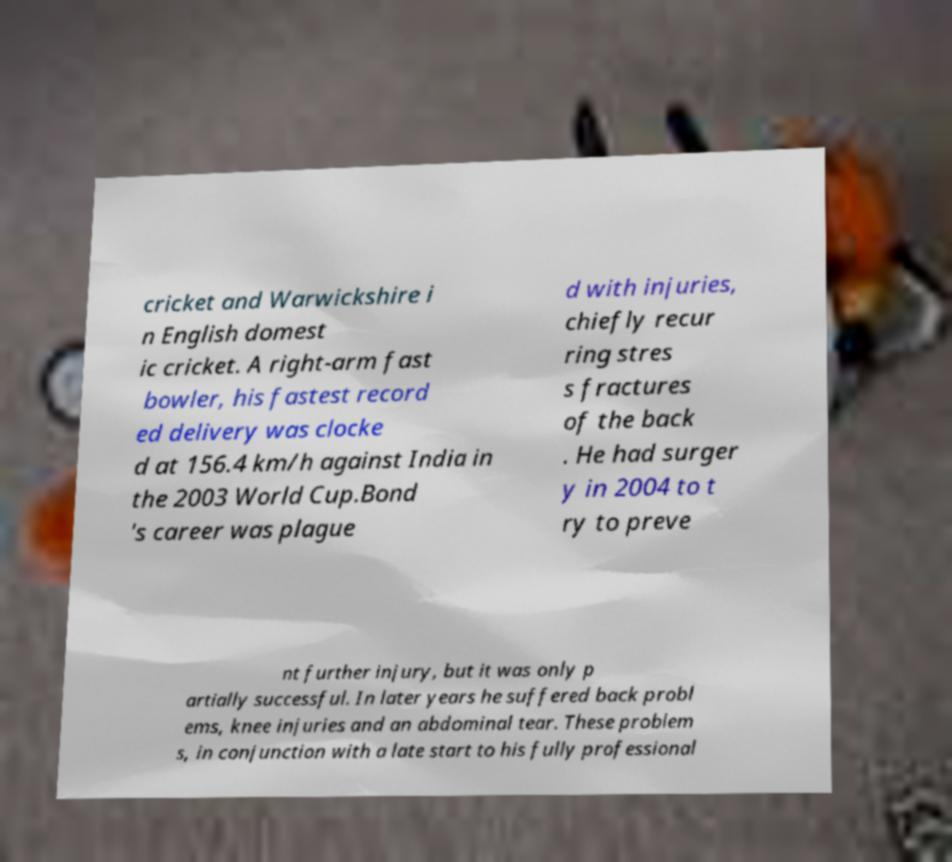Please read and relay the text visible in this image. What does it say? cricket and Warwickshire i n English domest ic cricket. A right-arm fast bowler, his fastest record ed delivery was clocke d at 156.4 km/h against India in the 2003 World Cup.Bond 's career was plague d with injuries, chiefly recur ring stres s fractures of the back . He had surger y in 2004 to t ry to preve nt further injury, but it was only p artially successful. In later years he suffered back probl ems, knee injuries and an abdominal tear. These problem s, in conjunction with a late start to his fully professional 